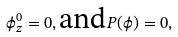<formula> <loc_0><loc_0><loc_500><loc_500>\phi ^ { 0 } _ { z } = 0 , \text {and} P ( \phi ) = 0 ,</formula> 